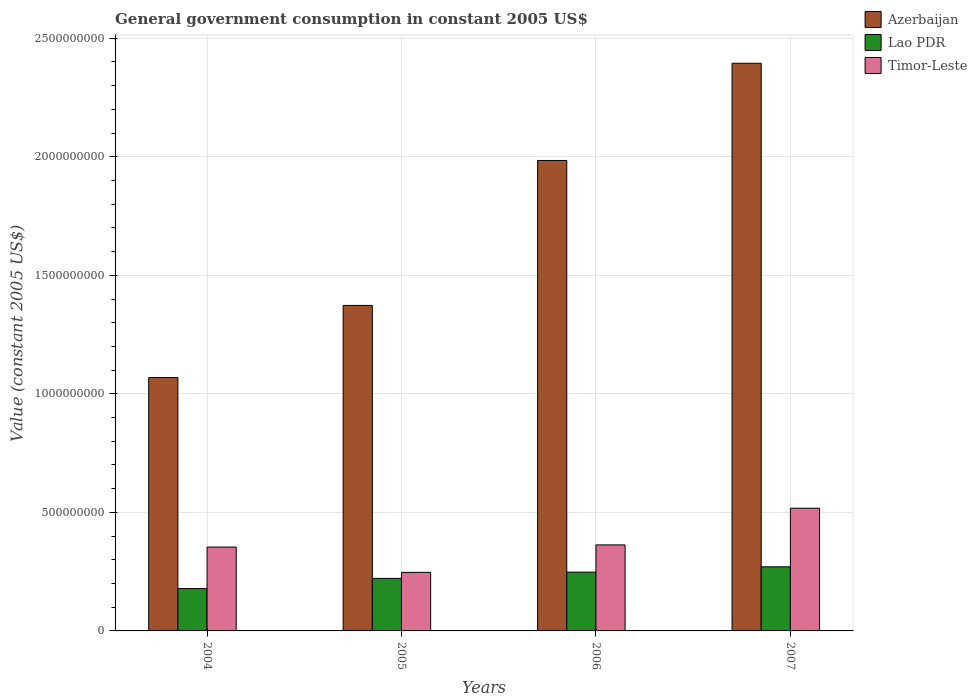Are the number of bars per tick equal to the number of legend labels?
Give a very brief answer. Yes. How many bars are there on the 1st tick from the right?
Keep it short and to the point. 3. What is the label of the 4th group of bars from the left?
Provide a short and direct response. 2007. What is the government conusmption in Timor-Leste in 2007?
Ensure brevity in your answer.  5.18e+08. Across all years, what is the maximum government conusmption in Lao PDR?
Your answer should be compact. 2.70e+08. Across all years, what is the minimum government conusmption in Azerbaijan?
Your answer should be very brief. 1.07e+09. In which year was the government conusmption in Lao PDR maximum?
Provide a succinct answer. 2007. What is the total government conusmption in Lao PDR in the graph?
Give a very brief answer. 9.19e+08. What is the difference between the government conusmption in Lao PDR in 2004 and that in 2005?
Make the answer very short. -4.29e+07. What is the difference between the government conusmption in Lao PDR in 2005 and the government conusmption in Azerbaijan in 2004?
Give a very brief answer. -8.47e+08. What is the average government conusmption in Lao PDR per year?
Ensure brevity in your answer.  2.30e+08. In the year 2005, what is the difference between the government conusmption in Timor-Leste and government conusmption in Azerbaijan?
Ensure brevity in your answer.  -1.13e+09. In how many years, is the government conusmption in Lao PDR greater than 600000000 US$?
Ensure brevity in your answer.  0. What is the ratio of the government conusmption in Azerbaijan in 2004 to that in 2005?
Offer a very short reply. 0.78. Is the government conusmption in Lao PDR in 2004 less than that in 2007?
Offer a very short reply. Yes. What is the difference between the highest and the second highest government conusmption in Timor-Leste?
Your response must be concise. 1.55e+08. What is the difference between the highest and the lowest government conusmption in Timor-Leste?
Give a very brief answer. 2.71e+08. Is the sum of the government conusmption in Azerbaijan in 2006 and 2007 greater than the maximum government conusmption in Timor-Leste across all years?
Your response must be concise. Yes. What does the 2nd bar from the left in 2004 represents?
Your answer should be very brief. Lao PDR. What does the 1st bar from the right in 2004 represents?
Your response must be concise. Timor-Leste. How many bars are there?
Keep it short and to the point. 12. Are all the bars in the graph horizontal?
Ensure brevity in your answer.  No. Are the values on the major ticks of Y-axis written in scientific E-notation?
Provide a short and direct response. No. How are the legend labels stacked?
Your answer should be very brief. Vertical. What is the title of the graph?
Provide a succinct answer. General government consumption in constant 2005 US$. Does "Vietnam" appear as one of the legend labels in the graph?
Offer a terse response. No. What is the label or title of the Y-axis?
Give a very brief answer. Value (constant 2005 US$). What is the Value (constant 2005 US$) in Azerbaijan in 2004?
Your answer should be compact. 1.07e+09. What is the Value (constant 2005 US$) in Lao PDR in 2004?
Offer a very short reply. 1.79e+08. What is the Value (constant 2005 US$) in Timor-Leste in 2004?
Provide a short and direct response. 3.54e+08. What is the Value (constant 2005 US$) of Azerbaijan in 2005?
Your answer should be very brief. 1.37e+09. What is the Value (constant 2005 US$) of Lao PDR in 2005?
Keep it short and to the point. 2.22e+08. What is the Value (constant 2005 US$) of Timor-Leste in 2005?
Offer a very short reply. 2.47e+08. What is the Value (constant 2005 US$) in Azerbaijan in 2006?
Give a very brief answer. 1.98e+09. What is the Value (constant 2005 US$) in Lao PDR in 2006?
Offer a terse response. 2.48e+08. What is the Value (constant 2005 US$) in Timor-Leste in 2006?
Ensure brevity in your answer.  3.63e+08. What is the Value (constant 2005 US$) of Azerbaijan in 2007?
Provide a succinct answer. 2.39e+09. What is the Value (constant 2005 US$) in Lao PDR in 2007?
Offer a terse response. 2.70e+08. What is the Value (constant 2005 US$) in Timor-Leste in 2007?
Your response must be concise. 5.18e+08. Across all years, what is the maximum Value (constant 2005 US$) in Azerbaijan?
Ensure brevity in your answer.  2.39e+09. Across all years, what is the maximum Value (constant 2005 US$) in Lao PDR?
Offer a very short reply. 2.70e+08. Across all years, what is the maximum Value (constant 2005 US$) of Timor-Leste?
Make the answer very short. 5.18e+08. Across all years, what is the minimum Value (constant 2005 US$) of Azerbaijan?
Offer a very short reply. 1.07e+09. Across all years, what is the minimum Value (constant 2005 US$) in Lao PDR?
Give a very brief answer. 1.79e+08. Across all years, what is the minimum Value (constant 2005 US$) of Timor-Leste?
Provide a short and direct response. 2.47e+08. What is the total Value (constant 2005 US$) in Azerbaijan in the graph?
Your answer should be very brief. 6.82e+09. What is the total Value (constant 2005 US$) of Lao PDR in the graph?
Your answer should be compact. 9.19e+08. What is the total Value (constant 2005 US$) in Timor-Leste in the graph?
Keep it short and to the point. 1.48e+09. What is the difference between the Value (constant 2005 US$) in Azerbaijan in 2004 and that in 2005?
Keep it short and to the point. -3.04e+08. What is the difference between the Value (constant 2005 US$) of Lao PDR in 2004 and that in 2005?
Ensure brevity in your answer.  -4.29e+07. What is the difference between the Value (constant 2005 US$) in Timor-Leste in 2004 and that in 2005?
Offer a terse response. 1.07e+08. What is the difference between the Value (constant 2005 US$) of Azerbaijan in 2004 and that in 2006?
Make the answer very short. -9.16e+08. What is the difference between the Value (constant 2005 US$) of Lao PDR in 2004 and that in 2006?
Provide a short and direct response. -6.93e+07. What is the difference between the Value (constant 2005 US$) in Timor-Leste in 2004 and that in 2006?
Your answer should be compact. -9.15e+06. What is the difference between the Value (constant 2005 US$) in Azerbaijan in 2004 and that in 2007?
Provide a succinct answer. -1.33e+09. What is the difference between the Value (constant 2005 US$) in Lao PDR in 2004 and that in 2007?
Provide a succinct answer. -9.17e+07. What is the difference between the Value (constant 2005 US$) in Timor-Leste in 2004 and that in 2007?
Offer a terse response. -1.64e+08. What is the difference between the Value (constant 2005 US$) of Azerbaijan in 2005 and that in 2006?
Your response must be concise. -6.11e+08. What is the difference between the Value (constant 2005 US$) of Lao PDR in 2005 and that in 2006?
Provide a succinct answer. -2.64e+07. What is the difference between the Value (constant 2005 US$) in Timor-Leste in 2005 and that in 2006?
Provide a succinct answer. -1.16e+08. What is the difference between the Value (constant 2005 US$) in Azerbaijan in 2005 and that in 2007?
Offer a very short reply. -1.02e+09. What is the difference between the Value (constant 2005 US$) in Lao PDR in 2005 and that in 2007?
Your answer should be compact. -4.88e+07. What is the difference between the Value (constant 2005 US$) of Timor-Leste in 2005 and that in 2007?
Provide a short and direct response. -2.71e+08. What is the difference between the Value (constant 2005 US$) in Azerbaijan in 2006 and that in 2007?
Ensure brevity in your answer.  -4.10e+08. What is the difference between the Value (constant 2005 US$) in Lao PDR in 2006 and that in 2007?
Your answer should be very brief. -2.24e+07. What is the difference between the Value (constant 2005 US$) of Timor-Leste in 2006 and that in 2007?
Provide a short and direct response. -1.55e+08. What is the difference between the Value (constant 2005 US$) of Azerbaijan in 2004 and the Value (constant 2005 US$) of Lao PDR in 2005?
Give a very brief answer. 8.47e+08. What is the difference between the Value (constant 2005 US$) of Azerbaijan in 2004 and the Value (constant 2005 US$) of Timor-Leste in 2005?
Offer a terse response. 8.22e+08. What is the difference between the Value (constant 2005 US$) of Lao PDR in 2004 and the Value (constant 2005 US$) of Timor-Leste in 2005?
Provide a short and direct response. -6.83e+07. What is the difference between the Value (constant 2005 US$) in Azerbaijan in 2004 and the Value (constant 2005 US$) in Lao PDR in 2006?
Keep it short and to the point. 8.21e+08. What is the difference between the Value (constant 2005 US$) in Azerbaijan in 2004 and the Value (constant 2005 US$) in Timor-Leste in 2006?
Keep it short and to the point. 7.06e+08. What is the difference between the Value (constant 2005 US$) in Lao PDR in 2004 and the Value (constant 2005 US$) in Timor-Leste in 2006?
Keep it short and to the point. -1.84e+08. What is the difference between the Value (constant 2005 US$) in Azerbaijan in 2004 and the Value (constant 2005 US$) in Lao PDR in 2007?
Provide a succinct answer. 7.99e+08. What is the difference between the Value (constant 2005 US$) of Azerbaijan in 2004 and the Value (constant 2005 US$) of Timor-Leste in 2007?
Make the answer very short. 5.51e+08. What is the difference between the Value (constant 2005 US$) of Lao PDR in 2004 and the Value (constant 2005 US$) of Timor-Leste in 2007?
Make the answer very short. -3.39e+08. What is the difference between the Value (constant 2005 US$) of Azerbaijan in 2005 and the Value (constant 2005 US$) of Lao PDR in 2006?
Make the answer very short. 1.13e+09. What is the difference between the Value (constant 2005 US$) of Azerbaijan in 2005 and the Value (constant 2005 US$) of Timor-Leste in 2006?
Your answer should be compact. 1.01e+09. What is the difference between the Value (constant 2005 US$) in Lao PDR in 2005 and the Value (constant 2005 US$) in Timor-Leste in 2006?
Make the answer very short. -1.41e+08. What is the difference between the Value (constant 2005 US$) in Azerbaijan in 2005 and the Value (constant 2005 US$) in Lao PDR in 2007?
Provide a succinct answer. 1.10e+09. What is the difference between the Value (constant 2005 US$) in Azerbaijan in 2005 and the Value (constant 2005 US$) in Timor-Leste in 2007?
Your response must be concise. 8.55e+08. What is the difference between the Value (constant 2005 US$) of Lao PDR in 2005 and the Value (constant 2005 US$) of Timor-Leste in 2007?
Your answer should be compact. -2.96e+08. What is the difference between the Value (constant 2005 US$) of Azerbaijan in 2006 and the Value (constant 2005 US$) of Lao PDR in 2007?
Offer a terse response. 1.71e+09. What is the difference between the Value (constant 2005 US$) of Azerbaijan in 2006 and the Value (constant 2005 US$) of Timor-Leste in 2007?
Your answer should be compact. 1.47e+09. What is the difference between the Value (constant 2005 US$) in Lao PDR in 2006 and the Value (constant 2005 US$) in Timor-Leste in 2007?
Offer a terse response. -2.70e+08. What is the average Value (constant 2005 US$) in Azerbaijan per year?
Your response must be concise. 1.71e+09. What is the average Value (constant 2005 US$) of Lao PDR per year?
Ensure brevity in your answer.  2.30e+08. What is the average Value (constant 2005 US$) in Timor-Leste per year?
Keep it short and to the point. 3.70e+08. In the year 2004, what is the difference between the Value (constant 2005 US$) of Azerbaijan and Value (constant 2005 US$) of Lao PDR?
Your answer should be compact. 8.90e+08. In the year 2004, what is the difference between the Value (constant 2005 US$) of Azerbaijan and Value (constant 2005 US$) of Timor-Leste?
Your response must be concise. 7.15e+08. In the year 2004, what is the difference between the Value (constant 2005 US$) in Lao PDR and Value (constant 2005 US$) in Timor-Leste?
Offer a terse response. -1.75e+08. In the year 2005, what is the difference between the Value (constant 2005 US$) of Azerbaijan and Value (constant 2005 US$) of Lao PDR?
Make the answer very short. 1.15e+09. In the year 2005, what is the difference between the Value (constant 2005 US$) in Azerbaijan and Value (constant 2005 US$) in Timor-Leste?
Provide a succinct answer. 1.13e+09. In the year 2005, what is the difference between the Value (constant 2005 US$) of Lao PDR and Value (constant 2005 US$) of Timor-Leste?
Your response must be concise. -2.55e+07. In the year 2006, what is the difference between the Value (constant 2005 US$) in Azerbaijan and Value (constant 2005 US$) in Lao PDR?
Your response must be concise. 1.74e+09. In the year 2006, what is the difference between the Value (constant 2005 US$) of Azerbaijan and Value (constant 2005 US$) of Timor-Leste?
Give a very brief answer. 1.62e+09. In the year 2006, what is the difference between the Value (constant 2005 US$) in Lao PDR and Value (constant 2005 US$) in Timor-Leste?
Your answer should be compact. -1.15e+08. In the year 2007, what is the difference between the Value (constant 2005 US$) in Azerbaijan and Value (constant 2005 US$) in Lao PDR?
Keep it short and to the point. 2.12e+09. In the year 2007, what is the difference between the Value (constant 2005 US$) of Azerbaijan and Value (constant 2005 US$) of Timor-Leste?
Provide a short and direct response. 1.88e+09. In the year 2007, what is the difference between the Value (constant 2005 US$) in Lao PDR and Value (constant 2005 US$) in Timor-Leste?
Your answer should be compact. -2.47e+08. What is the ratio of the Value (constant 2005 US$) of Azerbaijan in 2004 to that in 2005?
Keep it short and to the point. 0.78. What is the ratio of the Value (constant 2005 US$) of Lao PDR in 2004 to that in 2005?
Your response must be concise. 0.81. What is the ratio of the Value (constant 2005 US$) in Timor-Leste in 2004 to that in 2005?
Provide a succinct answer. 1.43. What is the ratio of the Value (constant 2005 US$) in Azerbaijan in 2004 to that in 2006?
Make the answer very short. 0.54. What is the ratio of the Value (constant 2005 US$) of Lao PDR in 2004 to that in 2006?
Keep it short and to the point. 0.72. What is the ratio of the Value (constant 2005 US$) of Timor-Leste in 2004 to that in 2006?
Your response must be concise. 0.97. What is the ratio of the Value (constant 2005 US$) of Azerbaijan in 2004 to that in 2007?
Offer a terse response. 0.45. What is the ratio of the Value (constant 2005 US$) in Lao PDR in 2004 to that in 2007?
Provide a short and direct response. 0.66. What is the ratio of the Value (constant 2005 US$) of Timor-Leste in 2004 to that in 2007?
Offer a very short reply. 0.68. What is the ratio of the Value (constant 2005 US$) in Azerbaijan in 2005 to that in 2006?
Provide a short and direct response. 0.69. What is the ratio of the Value (constant 2005 US$) in Lao PDR in 2005 to that in 2006?
Provide a short and direct response. 0.89. What is the ratio of the Value (constant 2005 US$) of Timor-Leste in 2005 to that in 2006?
Offer a terse response. 0.68. What is the ratio of the Value (constant 2005 US$) of Azerbaijan in 2005 to that in 2007?
Your answer should be very brief. 0.57. What is the ratio of the Value (constant 2005 US$) of Lao PDR in 2005 to that in 2007?
Your response must be concise. 0.82. What is the ratio of the Value (constant 2005 US$) in Timor-Leste in 2005 to that in 2007?
Offer a terse response. 0.48. What is the ratio of the Value (constant 2005 US$) in Azerbaijan in 2006 to that in 2007?
Keep it short and to the point. 0.83. What is the ratio of the Value (constant 2005 US$) in Lao PDR in 2006 to that in 2007?
Offer a terse response. 0.92. What is the ratio of the Value (constant 2005 US$) in Timor-Leste in 2006 to that in 2007?
Provide a short and direct response. 0.7. What is the difference between the highest and the second highest Value (constant 2005 US$) of Azerbaijan?
Keep it short and to the point. 4.10e+08. What is the difference between the highest and the second highest Value (constant 2005 US$) of Lao PDR?
Your answer should be compact. 2.24e+07. What is the difference between the highest and the second highest Value (constant 2005 US$) of Timor-Leste?
Make the answer very short. 1.55e+08. What is the difference between the highest and the lowest Value (constant 2005 US$) of Azerbaijan?
Your response must be concise. 1.33e+09. What is the difference between the highest and the lowest Value (constant 2005 US$) of Lao PDR?
Give a very brief answer. 9.17e+07. What is the difference between the highest and the lowest Value (constant 2005 US$) of Timor-Leste?
Make the answer very short. 2.71e+08. 